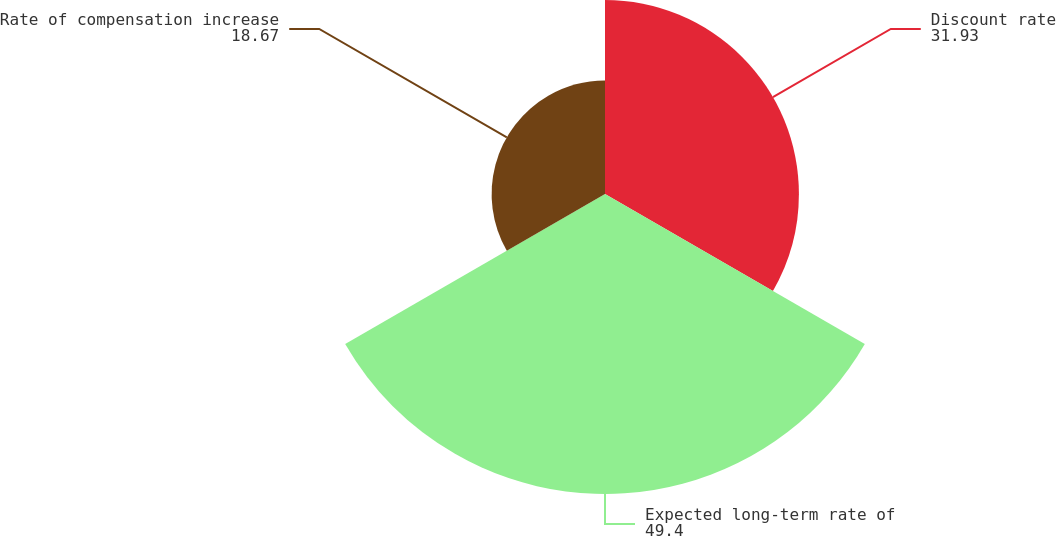Convert chart to OTSL. <chart><loc_0><loc_0><loc_500><loc_500><pie_chart><fcel>Discount rate<fcel>Expected long-term rate of<fcel>Rate of compensation increase<nl><fcel>31.93%<fcel>49.4%<fcel>18.67%<nl></chart> 